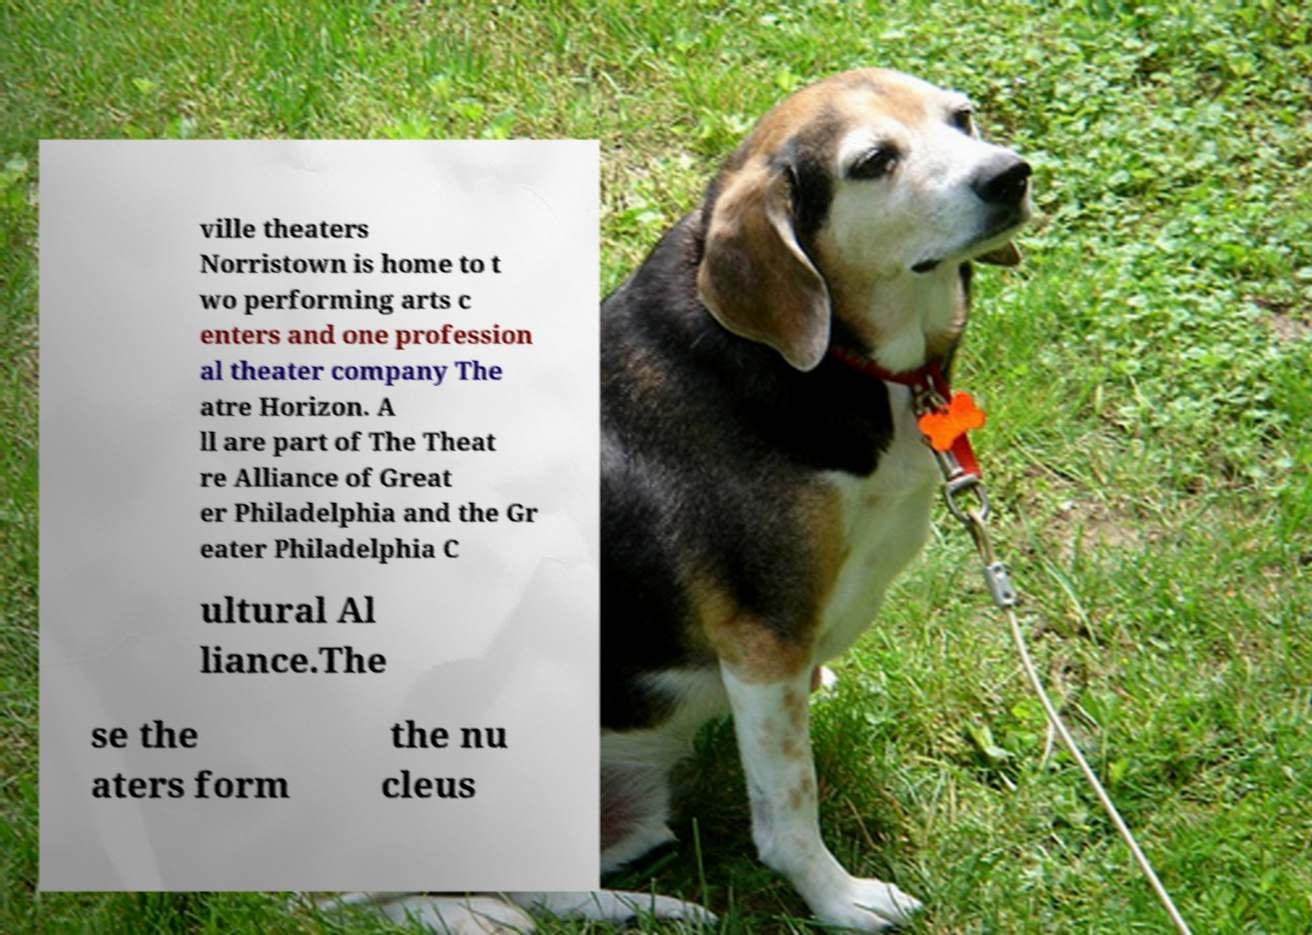For documentation purposes, I need the text within this image transcribed. Could you provide that? ville theaters Norristown is home to t wo performing arts c enters and one profession al theater company The atre Horizon. A ll are part of The Theat re Alliance of Great er Philadelphia and the Gr eater Philadelphia C ultural Al liance.The se the aters form the nu cleus 